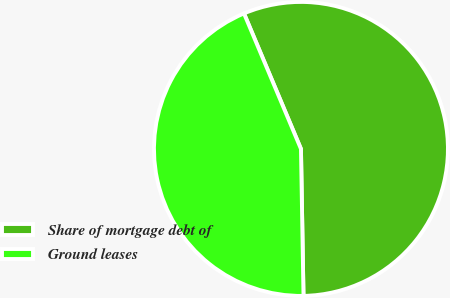Convert chart. <chart><loc_0><loc_0><loc_500><loc_500><pie_chart><fcel>Share of mortgage debt of<fcel>Ground leases<nl><fcel>56.06%<fcel>43.94%<nl></chart> 